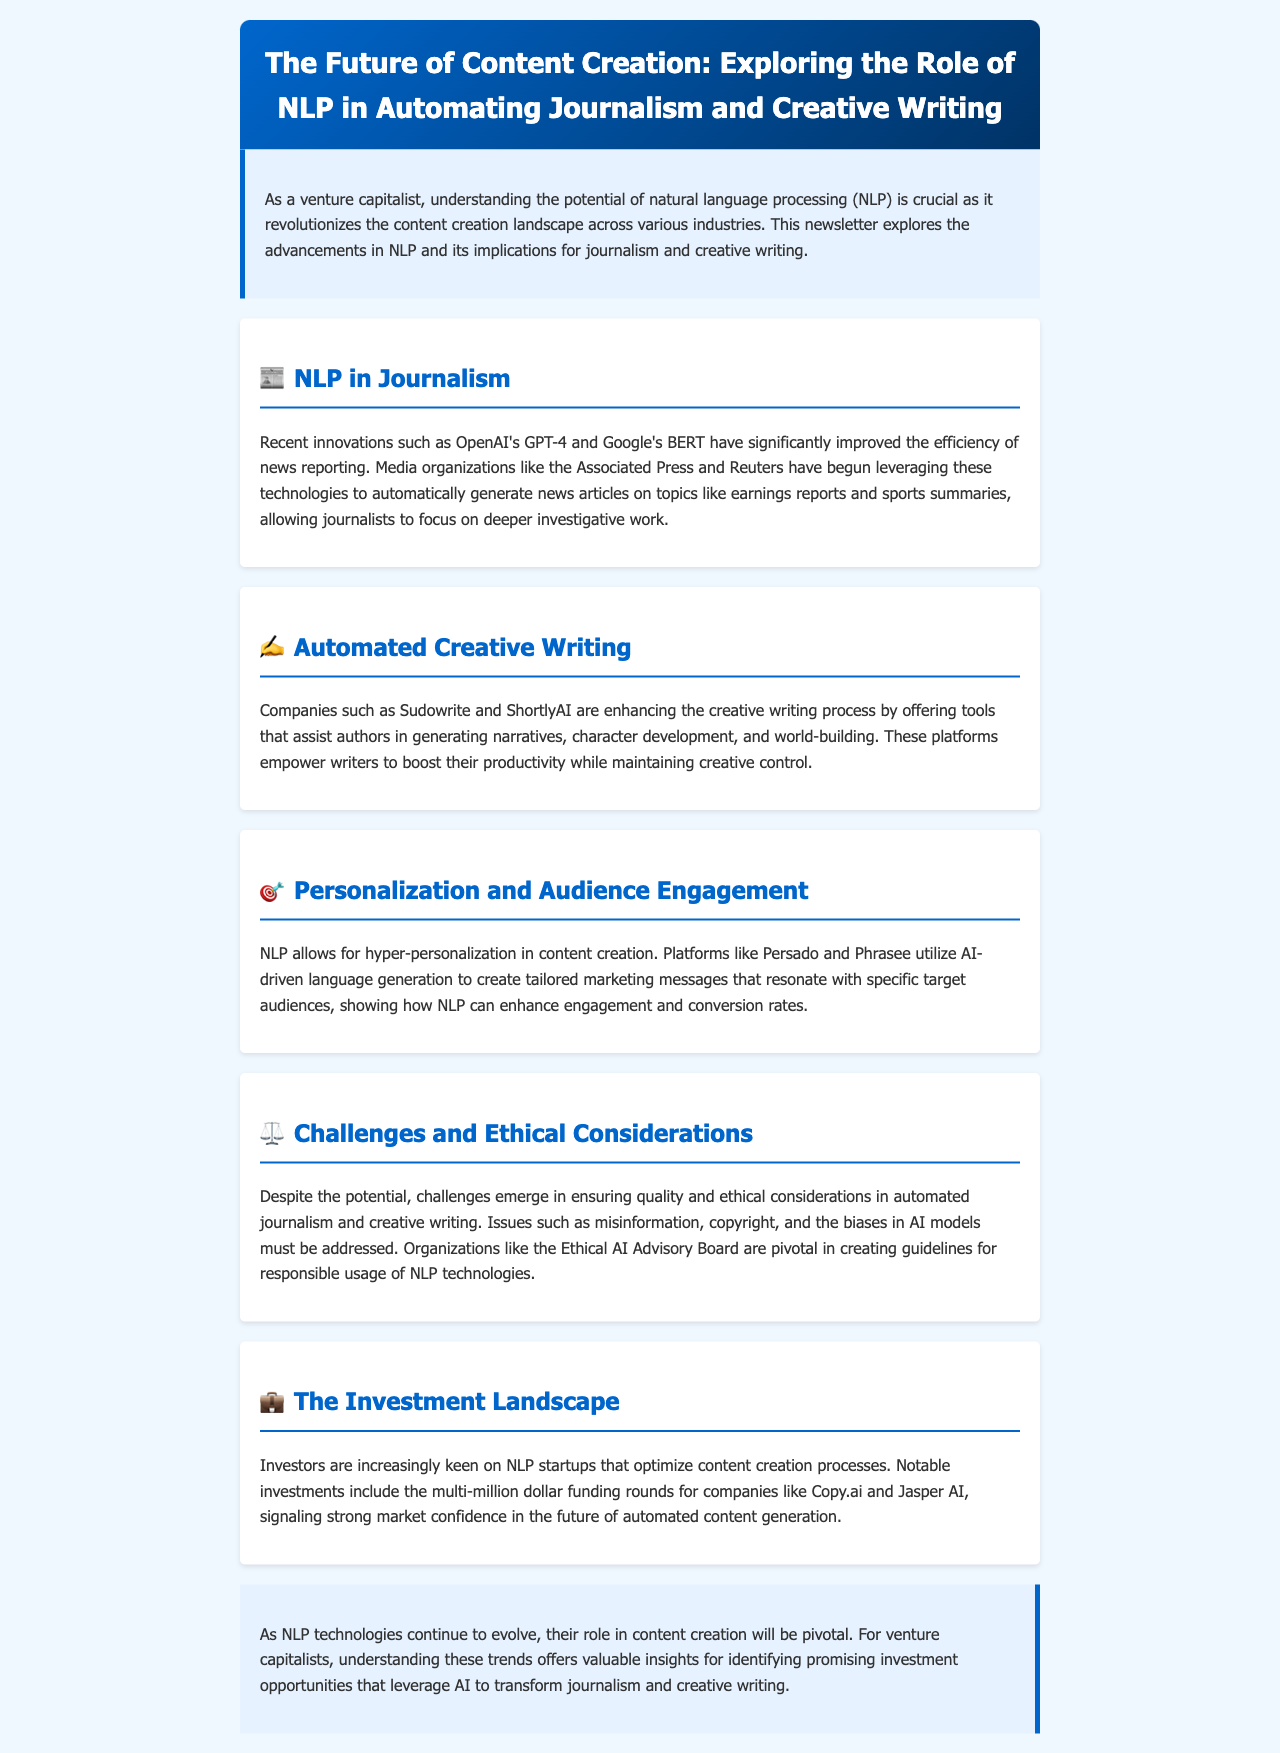What is the title of the newsletter? The title of the newsletter is found in the header section of the document.
Answer: The Future of Content Creation: Exploring the Role of NLP in Automating Journalism and Creative Writing What technology has significantly improved news reporting efficiency? The document mentions specific NLP technologies that have enhanced the efficiency in journalism.
Answer: GPT-4 and BERT Which media organization has begun leveraging NLP technologies for automated news articles? The document lists organizations using NLP technologies in journalism.
Answer: Associated Press Name a tool that assists authors in generating narratives. The section on automated creative writing lists specific companies that provide tools for writers.
Answer: Sudowrite What type of personalization does NLP allow in content creation? The document describes how NLP enhances audience engagement through specific methodologies.
Answer: Hyper-personalization What challenges are mentioned concerning automated journalism? The document discusses various issues that arise with the use of automated technologies in journalism and writing.
Answer: Misinformation Which organization is pivotal in creating guidelines for responsible NLP usage? The challenges and ethical considerations section includes organizations involved in guiding responsible technology usage.
Answer: Ethical AI Advisory Board What is the investment landscape regarding NLP startups? The investment landscape section outlines the trend of investments in NLP startups and references notable funding activities.
Answer: Multi-million dollar funding rounds Name a company that received significant investment in the NLP sector. The document provides examples of companies that have attracted investor interest in NLP technologies.
Answer: Copy.ai 